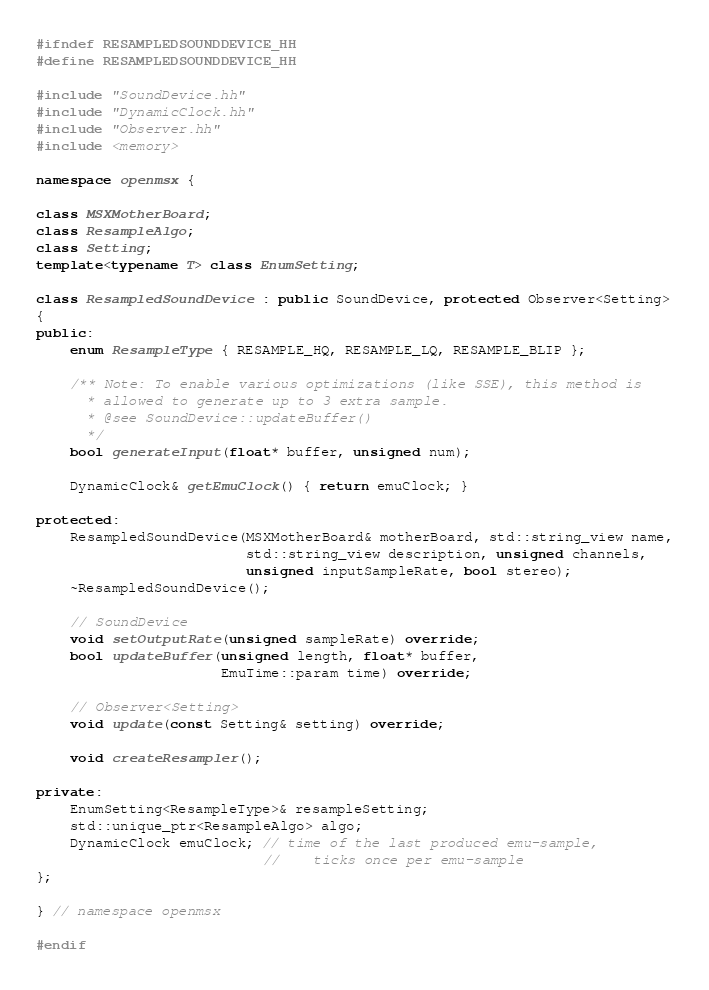<code> <loc_0><loc_0><loc_500><loc_500><_C++_>#ifndef RESAMPLEDSOUNDDEVICE_HH
#define RESAMPLEDSOUNDDEVICE_HH

#include "SoundDevice.hh"
#include "DynamicClock.hh"
#include "Observer.hh"
#include <memory>

namespace openmsx {

class MSXMotherBoard;
class ResampleAlgo;
class Setting;
template<typename T> class EnumSetting;

class ResampledSoundDevice : public SoundDevice, protected Observer<Setting>
{
public:
	enum ResampleType { RESAMPLE_HQ, RESAMPLE_LQ, RESAMPLE_BLIP };

	/** Note: To enable various optimizations (like SSE), this method is
	  * allowed to generate up to 3 extra sample.
	  * @see SoundDevice::updateBuffer()
	  */
	bool generateInput(float* buffer, unsigned num);

	DynamicClock& getEmuClock() { return emuClock; }

protected:
	ResampledSoundDevice(MSXMotherBoard& motherBoard, std::string_view name,
	                     std::string_view description, unsigned channels,
	                     unsigned inputSampleRate, bool stereo);
	~ResampledSoundDevice();

	// SoundDevice
	void setOutputRate(unsigned sampleRate) override;
	bool updateBuffer(unsigned length, float* buffer,
	                  EmuTime::param time) override;

	// Observer<Setting>
	void update(const Setting& setting) override;

	void createResampler();

private:
	EnumSetting<ResampleType>& resampleSetting;
	std::unique_ptr<ResampleAlgo> algo;
	DynamicClock emuClock; // time of the last produced emu-sample,
	                       //    ticks once per emu-sample
};

} // namespace openmsx

#endif
</code> 